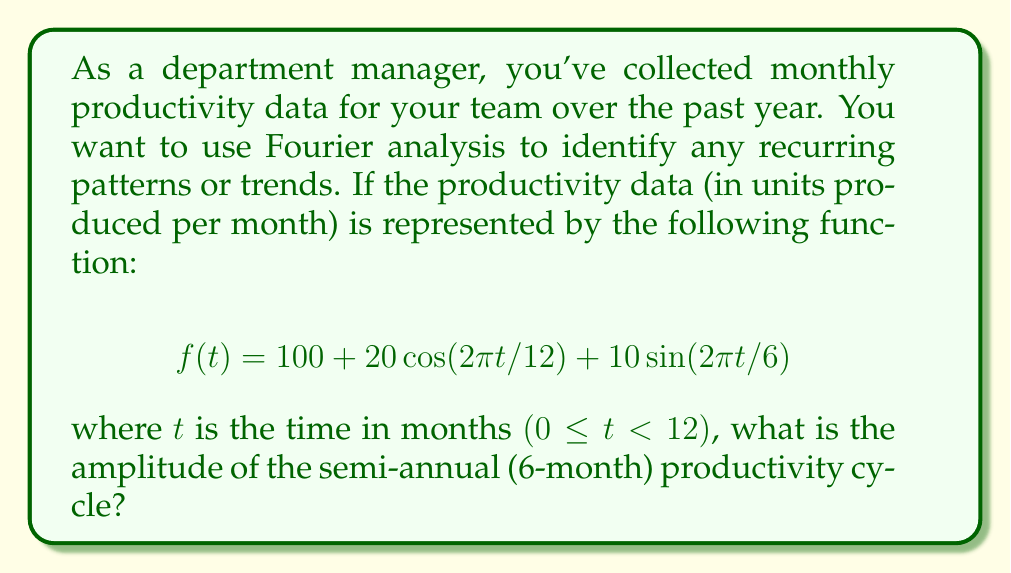Teach me how to tackle this problem. To solve this problem, we need to analyze the given function using Fourier analysis principles:

1. The function $f(t)$ represents the productivity over time and is composed of three terms:
   - A constant term: 100 (average productivity)
   - A cosine term: $20\cos(2\pi t/12)$
   - A sine term: $10\sin(2\pi t/6)$

2. In Fourier analysis, cosine and sine terms represent cyclical patterns. The frequency of these cycles is determined by the denominator in the argument of the trigonometric functions.

3. For the cosine term:
   $20\cos(2\pi t/12)$ has a period of 12 months, representing an annual cycle.

4. For the sine term:
   $10\sin(2\pi t/6)$ has a period of 6 months, representing a semi-annual cycle.

5. The amplitude of a cycle is the maximum deviation from the average. In a sinusoidal function $a\sin(bt)$ or $a\cos(bt)$, the amplitude is given by the coefficient $a$.

6. Therefore, the amplitude of the semi-annual cycle is the coefficient of the sine term with a 6-month period, which is 10.

This analysis allows us to identify that there is indeed a semi-annual productivity cycle with an amplitude of 10 units, which could be useful information for planning and resource allocation as a department manager.
Answer: The amplitude of the semi-annual productivity cycle is 10 units. 